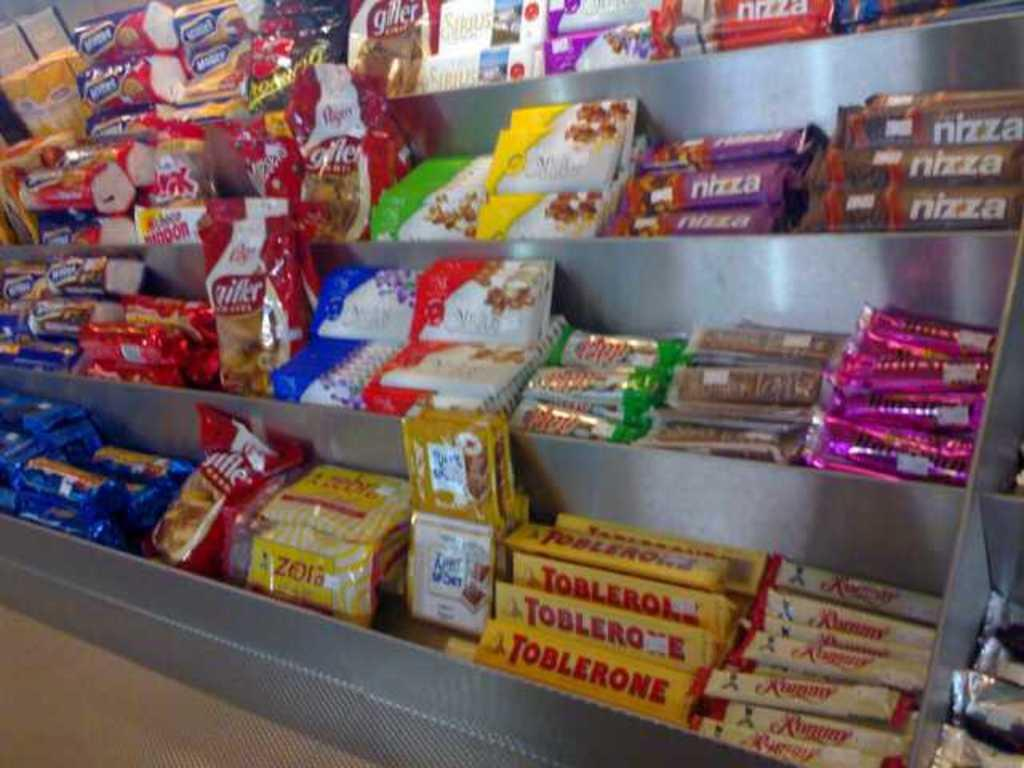<image>
Present a compact description of the photo's key features. An assortment of candy including some named Toblerone. 